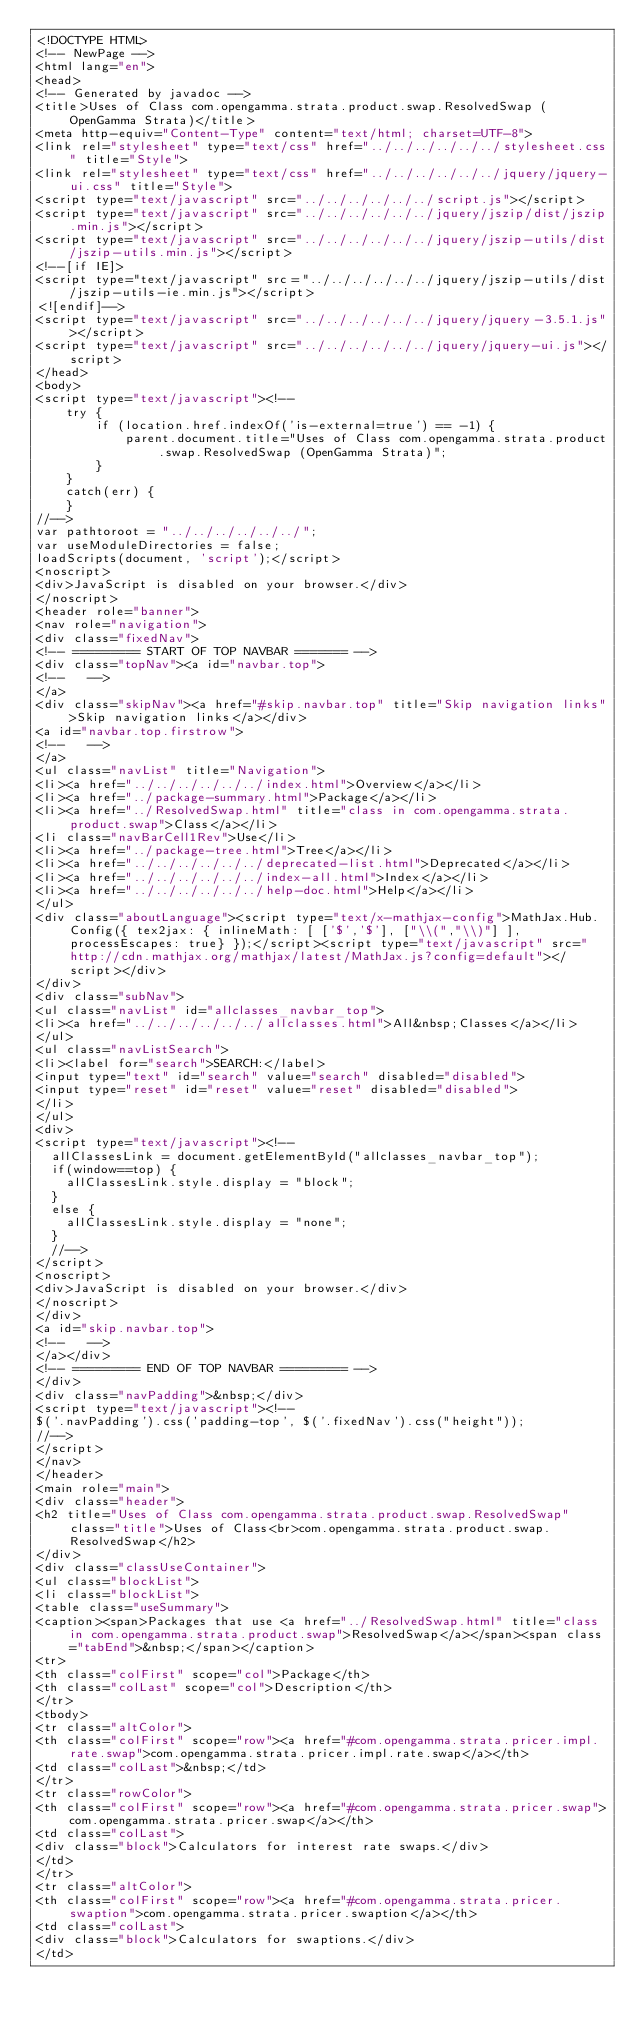<code> <loc_0><loc_0><loc_500><loc_500><_HTML_><!DOCTYPE HTML>
<!-- NewPage -->
<html lang="en">
<head>
<!-- Generated by javadoc -->
<title>Uses of Class com.opengamma.strata.product.swap.ResolvedSwap (OpenGamma Strata)</title>
<meta http-equiv="Content-Type" content="text/html; charset=UTF-8">
<link rel="stylesheet" type="text/css" href="../../../../../../stylesheet.css" title="Style">
<link rel="stylesheet" type="text/css" href="../../../../../../jquery/jquery-ui.css" title="Style">
<script type="text/javascript" src="../../../../../../script.js"></script>
<script type="text/javascript" src="../../../../../../jquery/jszip/dist/jszip.min.js"></script>
<script type="text/javascript" src="../../../../../../jquery/jszip-utils/dist/jszip-utils.min.js"></script>
<!--[if IE]>
<script type="text/javascript" src="../../../../../../jquery/jszip-utils/dist/jszip-utils-ie.min.js"></script>
<![endif]-->
<script type="text/javascript" src="../../../../../../jquery/jquery-3.5.1.js"></script>
<script type="text/javascript" src="../../../../../../jquery/jquery-ui.js"></script>
</head>
<body>
<script type="text/javascript"><!--
    try {
        if (location.href.indexOf('is-external=true') == -1) {
            parent.document.title="Uses of Class com.opengamma.strata.product.swap.ResolvedSwap (OpenGamma Strata)";
        }
    }
    catch(err) {
    }
//-->
var pathtoroot = "../../../../../../";
var useModuleDirectories = false;
loadScripts(document, 'script');</script>
<noscript>
<div>JavaScript is disabled on your browser.</div>
</noscript>
<header role="banner">
<nav role="navigation">
<div class="fixedNav">
<!-- ========= START OF TOP NAVBAR ======= -->
<div class="topNav"><a id="navbar.top">
<!--   -->
</a>
<div class="skipNav"><a href="#skip.navbar.top" title="Skip navigation links">Skip navigation links</a></div>
<a id="navbar.top.firstrow">
<!--   -->
</a>
<ul class="navList" title="Navigation">
<li><a href="../../../../../../index.html">Overview</a></li>
<li><a href="../package-summary.html">Package</a></li>
<li><a href="../ResolvedSwap.html" title="class in com.opengamma.strata.product.swap">Class</a></li>
<li class="navBarCell1Rev">Use</li>
<li><a href="../package-tree.html">Tree</a></li>
<li><a href="../../../../../../deprecated-list.html">Deprecated</a></li>
<li><a href="../../../../../../index-all.html">Index</a></li>
<li><a href="../../../../../../help-doc.html">Help</a></li>
</ul>
<div class="aboutLanguage"><script type="text/x-mathjax-config">MathJax.Hub.Config({ tex2jax: { inlineMath: [ ['$','$'], ["\\(","\\)"] ],processEscapes: true} });</script><script type="text/javascript" src="http://cdn.mathjax.org/mathjax/latest/MathJax.js?config=default"></script></div>
</div>
<div class="subNav">
<ul class="navList" id="allclasses_navbar_top">
<li><a href="../../../../../../allclasses.html">All&nbsp;Classes</a></li>
</ul>
<ul class="navListSearch">
<li><label for="search">SEARCH:</label>
<input type="text" id="search" value="search" disabled="disabled">
<input type="reset" id="reset" value="reset" disabled="disabled">
</li>
</ul>
<div>
<script type="text/javascript"><!--
  allClassesLink = document.getElementById("allclasses_navbar_top");
  if(window==top) {
    allClassesLink.style.display = "block";
  }
  else {
    allClassesLink.style.display = "none";
  }
  //-->
</script>
<noscript>
<div>JavaScript is disabled on your browser.</div>
</noscript>
</div>
<a id="skip.navbar.top">
<!--   -->
</a></div>
<!-- ========= END OF TOP NAVBAR ========= -->
</div>
<div class="navPadding">&nbsp;</div>
<script type="text/javascript"><!--
$('.navPadding').css('padding-top', $('.fixedNav').css("height"));
//-->
</script>
</nav>
</header>
<main role="main">
<div class="header">
<h2 title="Uses of Class com.opengamma.strata.product.swap.ResolvedSwap" class="title">Uses of Class<br>com.opengamma.strata.product.swap.ResolvedSwap</h2>
</div>
<div class="classUseContainer">
<ul class="blockList">
<li class="blockList">
<table class="useSummary">
<caption><span>Packages that use <a href="../ResolvedSwap.html" title="class in com.opengamma.strata.product.swap">ResolvedSwap</a></span><span class="tabEnd">&nbsp;</span></caption>
<tr>
<th class="colFirst" scope="col">Package</th>
<th class="colLast" scope="col">Description</th>
</tr>
<tbody>
<tr class="altColor">
<th class="colFirst" scope="row"><a href="#com.opengamma.strata.pricer.impl.rate.swap">com.opengamma.strata.pricer.impl.rate.swap</a></th>
<td class="colLast">&nbsp;</td>
</tr>
<tr class="rowColor">
<th class="colFirst" scope="row"><a href="#com.opengamma.strata.pricer.swap">com.opengamma.strata.pricer.swap</a></th>
<td class="colLast">
<div class="block">Calculators for interest rate swaps.</div>
</td>
</tr>
<tr class="altColor">
<th class="colFirst" scope="row"><a href="#com.opengamma.strata.pricer.swaption">com.opengamma.strata.pricer.swaption</a></th>
<td class="colLast">
<div class="block">Calculators for swaptions.</div>
</td></code> 